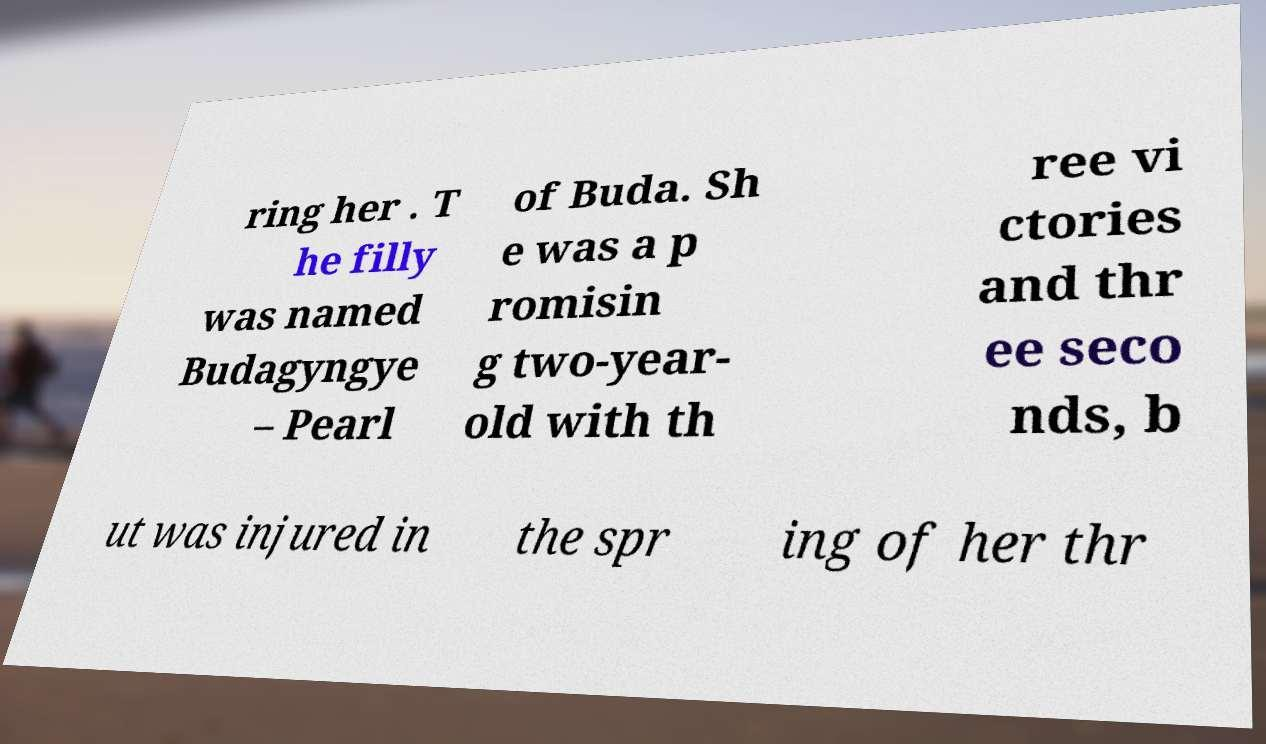I need the written content from this picture converted into text. Can you do that? ring her . T he filly was named Budagyngye – Pearl of Buda. Sh e was a p romisin g two-year- old with th ree vi ctories and thr ee seco nds, b ut was injured in the spr ing of her thr 